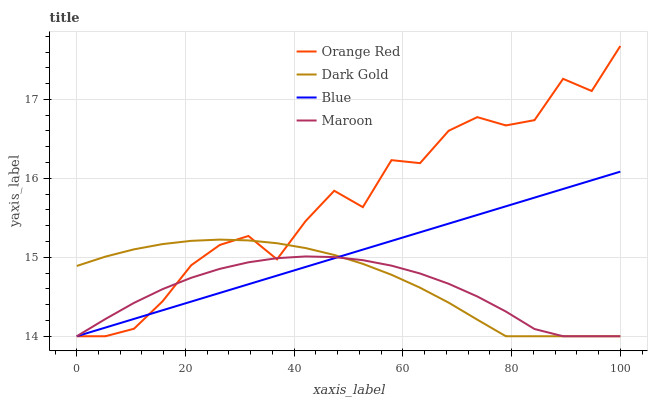Does Maroon have the minimum area under the curve?
Answer yes or no. Yes. Does Orange Red have the maximum area under the curve?
Answer yes or no. Yes. Does Orange Red have the minimum area under the curve?
Answer yes or no. No. Does Maroon have the maximum area under the curve?
Answer yes or no. No. Is Blue the smoothest?
Answer yes or no. Yes. Is Orange Red the roughest?
Answer yes or no. Yes. Is Maroon the smoothest?
Answer yes or no. No. Is Maroon the roughest?
Answer yes or no. No. Does Blue have the lowest value?
Answer yes or no. Yes. Does Orange Red have the highest value?
Answer yes or no. Yes. Does Maroon have the highest value?
Answer yes or no. No. Does Dark Gold intersect Maroon?
Answer yes or no. Yes. Is Dark Gold less than Maroon?
Answer yes or no. No. Is Dark Gold greater than Maroon?
Answer yes or no. No. 